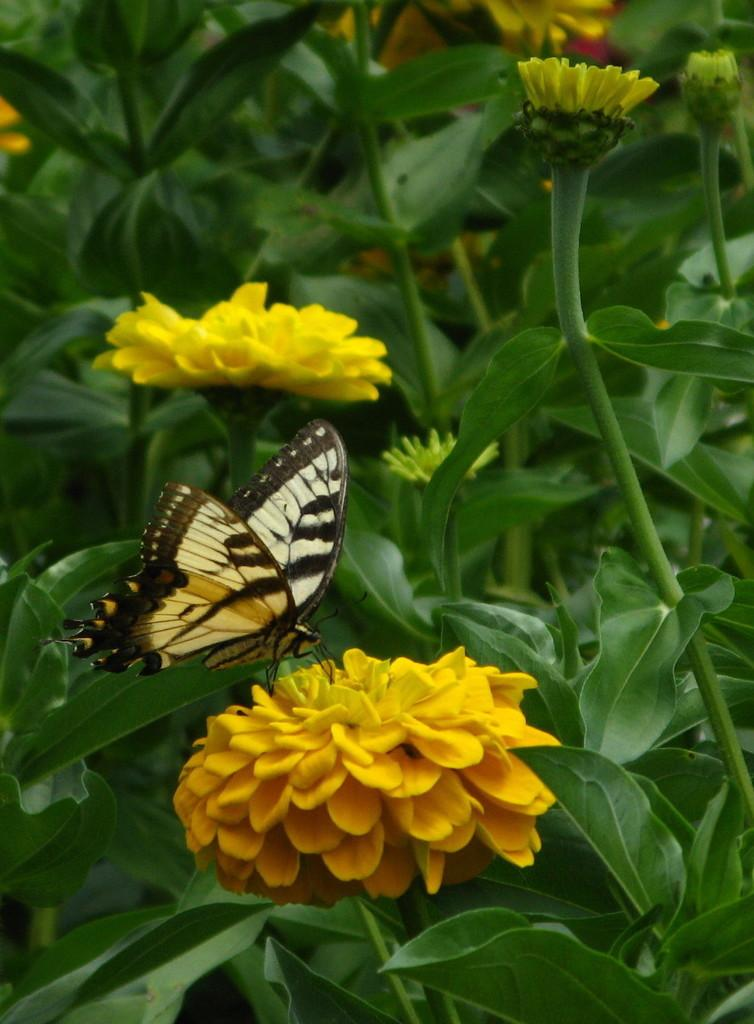What is the main subject of the image? There is a butterfly on a flower in the image. What can be seen in the background of the image? There are leaves and flowers in the background of the image. What type of test can be seen being conducted on the butterfly in the image? There is no test being conducted on the butterfly in the image; it is simply sitting on a flower. What type of metal is the butterfly made of in the image? The butterfly is not made of metal; it is a living creature. 